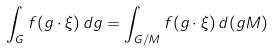Convert formula to latex. <formula><loc_0><loc_0><loc_500><loc_500>\int _ { G } f ( g \cdot \xi ) \, d g = \int _ { G / M } f ( g \cdot \xi ) \, d ( g M )</formula> 